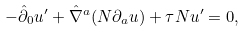Convert formula to latex. <formula><loc_0><loc_0><loc_500><loc_500>- \hat { \partial } _ { 0 } u ^ { \prime } + \hat { \nabla } ^ { a } ( N \partial _ { a } u ) + \tau N u ^ { \prime } = 0 ,</formula> 